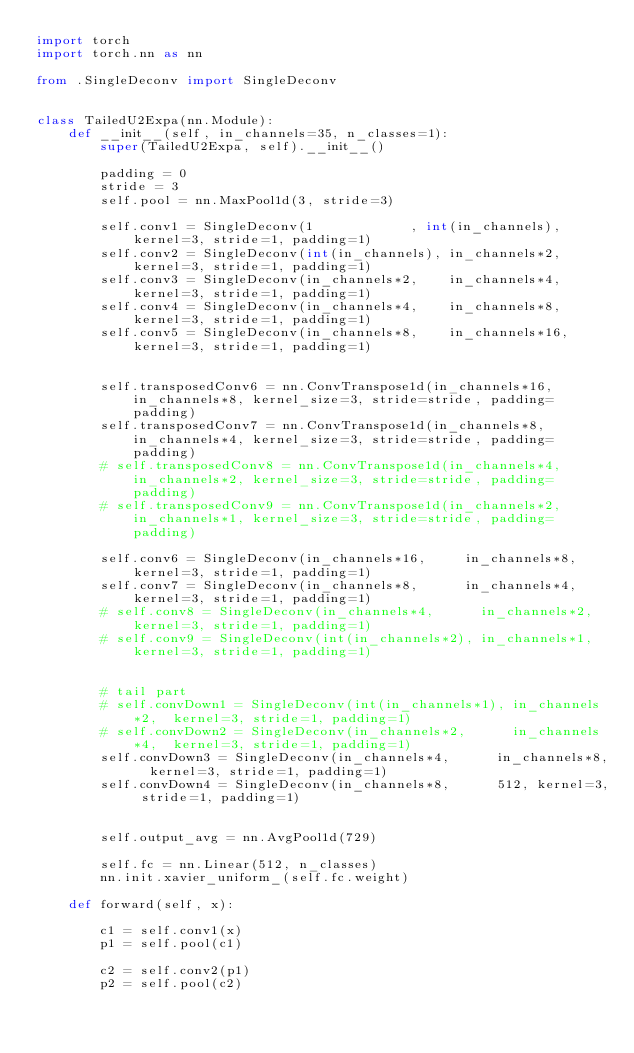<code> <loc_0><loc_0><loc_500><loc_500><_Python_>import torch
import torch.nn as nn

from .SingleDeconv import SingleDeconv


class TailedU2Expa(nn.Module):
    def __init__(self, in_channels=35, n_classes=1):
        super(TailedU2Expa, self).__init__()

        padding = 0
        stride = 3
        self.pool = nn.MaxPool1d(3, stride=3)
        
        self.conv1 = SingleDeconv(1            , int(in_channels),  kernel=3, stride=1, padding=1)
        self.conv2 = SingleDeconv(int(in_channels), in_channels*2,  kernel=3, stride=1, padding=1)
        self.conv3 = SingleDeconv(in_channels*2,    in_channels*4,  kernel=3, stride=1, padding=1)
        self.conv4 = SingleDeconv(in_channels*4,    in_channels*8,  kernel=3, stride=1, padding=1)
        self.conv5 = SingleDeconv(in_channels*8,    in_channels*16, kernel=3, stride=1, padding=1)
        
        
        self.transposedConv6 = nn.ConvTranspose1d(in_channels*16, in_channels*8, kernel_size=3, stride=stride, padding=padding)
        self.transposedConv7 = nn.ConvTranspose1d(in_channels*8,  in_channels*4, kernel_size=3, stride=stride, padding=padding)
        # self.transposedConv8 = nn.ConvTranspose1d(in_channels*4,  in_channels*2, kernel_size=3, stride=stride, padding=padding)
        # self.transposedConv9 = nn.ConvTranspose1d(in_channels*2,  in_channels*1, kernel_size=3, stride=stride, padding=padding)

        self.conv6 = SingleDeconv(in_channels*16,     in_channels*8, kernel=3, stride=1, padding=1)
        self.conv7 = SingleDeconv(in_channels*8,      in_channels*4, kernel=3, stride=1, padding=1)
        # self.conv8 = SingleDeconv(in_channels*4,      in_channels*2, kernel=3, stride=1, padding=1)
        # self.conv9 = SingleDeconv(int(in_channels*2), in_channels*1, kernel=3, stride=1, padding=1)


        # tail part
        # self.convDown1 = SingleDeconv(int(in_channels*1), in_channels*2,  kernel=3, stride=1, padding=1)
        # self.convDown2 = SingleDeconv(in_channels*2,      in_channels*4,  kernel=3, stride=1, padding=1)
        self.convDown3 = SingleDeconv(in_channels*4,      in_channels*8,  kernel=3, stride=1, padding=1)
        self.convDown4 = SingleDeconv(in_channels*8,      512, kernel=3, stride=1, padding=1)


        self.output_avg = nn.AvgPool1d(729)

        self.fc = nn.Linear(512, n_classes)
        nn.init.xavier_uniform_(self.fc.weight)

    def forward(self, x):

        c1 = self.conv1(x)
        p1 = self.pool(c1)

        c2 = self.conv2(p1)
        p2 = self.pool(c2)
</code> 